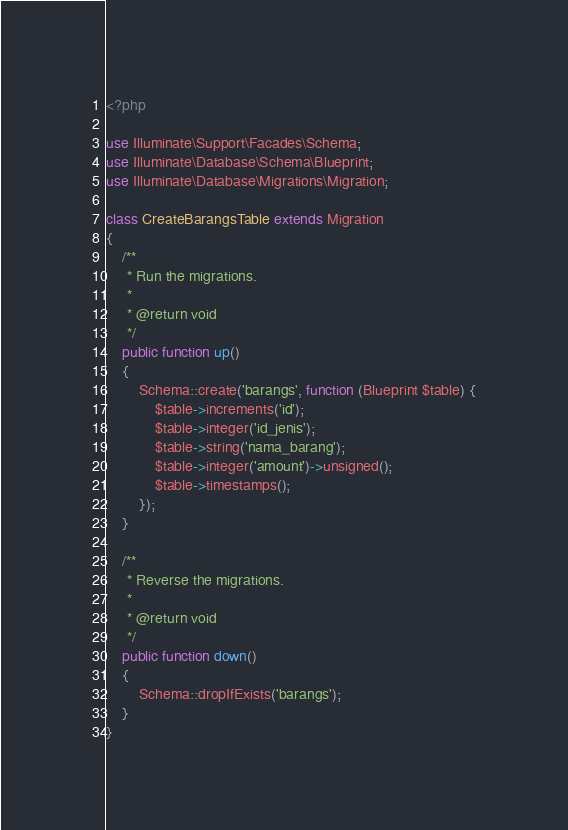Convert code to text. <code><loc_0><loc_0><loc_500><loc_500><_PHP_><?php

use Illuminate\Support\Facades\Schema;
use Illuminate\Database\Schema\Blueprint;
use Illuminate\Database\Migrations\Migration;

class CreateBarangsTable extends Migration
{
    /**
     * Run the migrations.
     *
     * @return void
     */
    public function up()
    {
        Schema::create('barangs', function (Blueprint $table) {
            $table->increments('id');
            $table->integer('id_jenis');
            $table->string('nama_barang');
            $table->integer('amount')->unsigned();
            $table->timestamps();
        });
    }

    /**
     * Reverse the migrations.
     *
     * @return void
     */
    public function down()
    {
        Schema::dropIfExists('barangs');
    }
}
</code> 